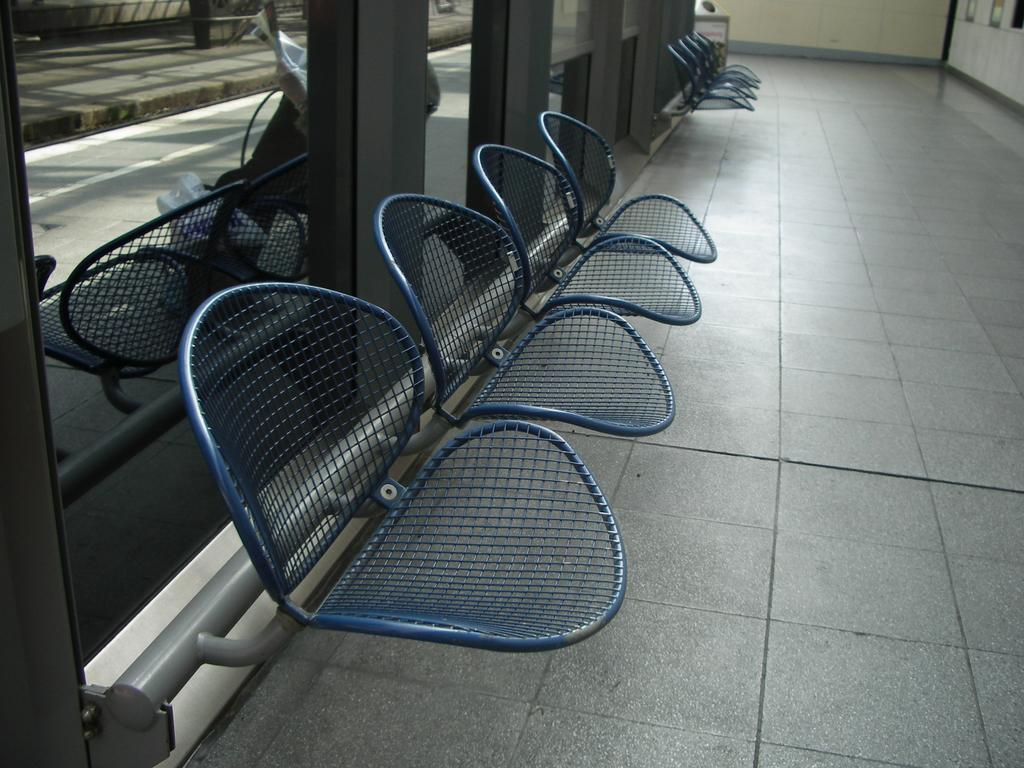What type of surface is present in the image? The image contains a floor. What type of furniture is present in the image? There are chairs in the image. What type of structure is present in the image? The image contains walls. What type of material is visible in the image? There is glass visible in the image. What type of outdoor area is visible in the background of the image? There is a road and a footpath in the background of the image. What type of objects are visible in the background of the image? There are objects visible in the background of the image. What type of activity is the person in the background of the image engaged in? There is a person sitting on a bench in the background of the image. What type of fruit is being sold by the person on the quince tree in the image? There is no quince tree or person selling fruit in the image. 